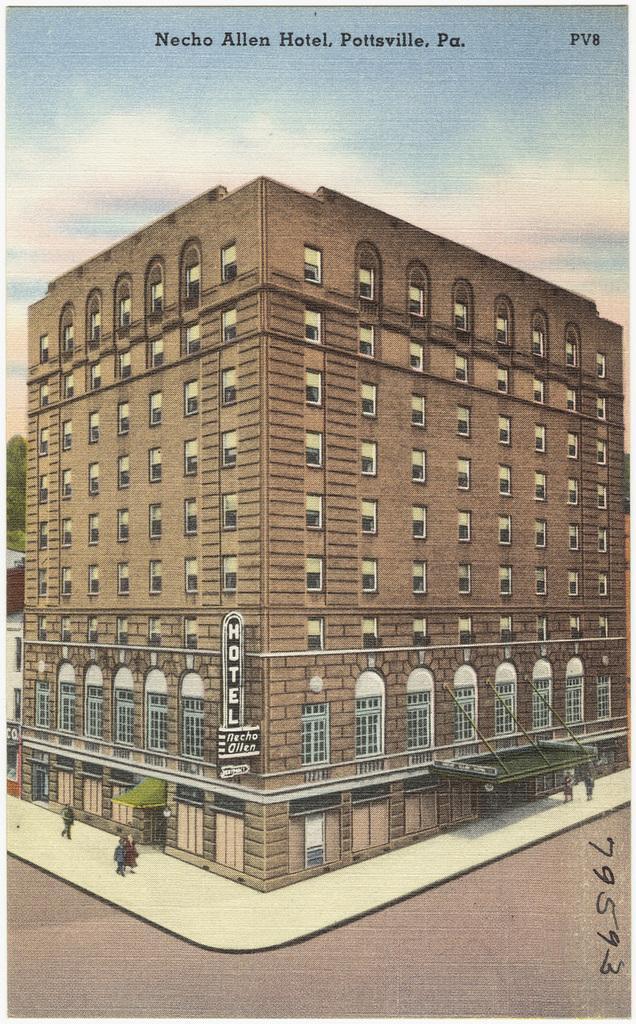Could you give a brief overview of what you see in this image? This picture describes about cover page, in this we can find a building. 